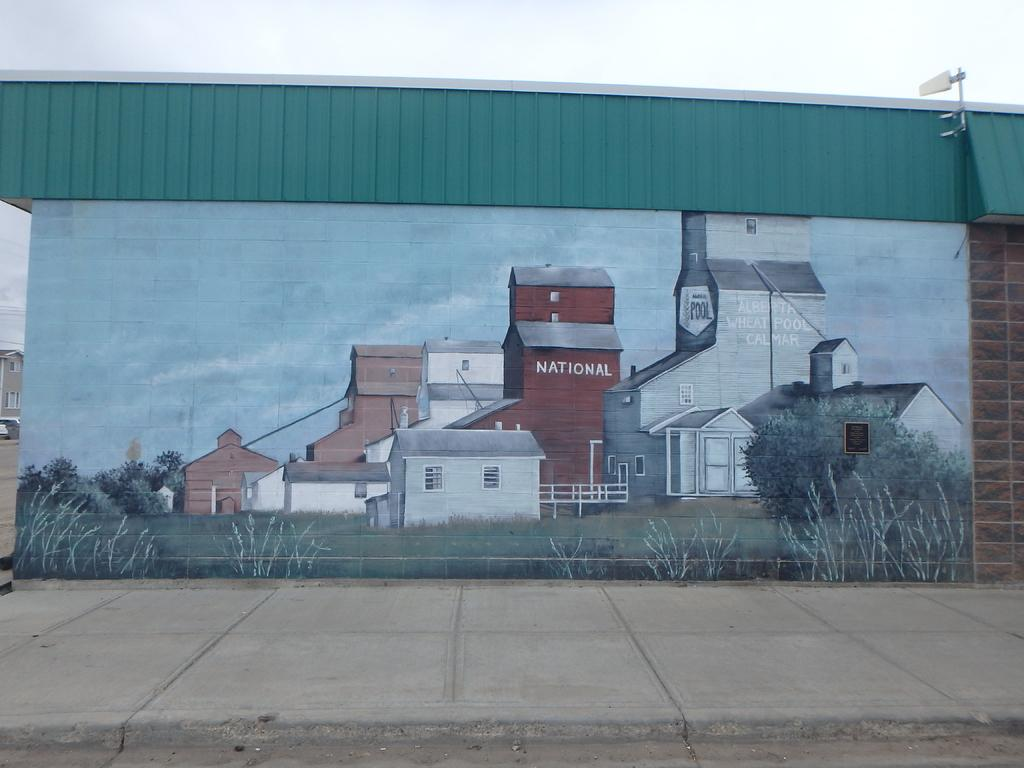What can be seen on the wall in the image? There are pictures on the wall in the image. What type of path is visible in the image? There is a footpath visible in the image. What part of the natural environment is visible in the image? The sky is visible in the image. How many friends are sitting in the cellar with the orange in the image? There is no mention of friends, a cellar, or an orange in the image. 